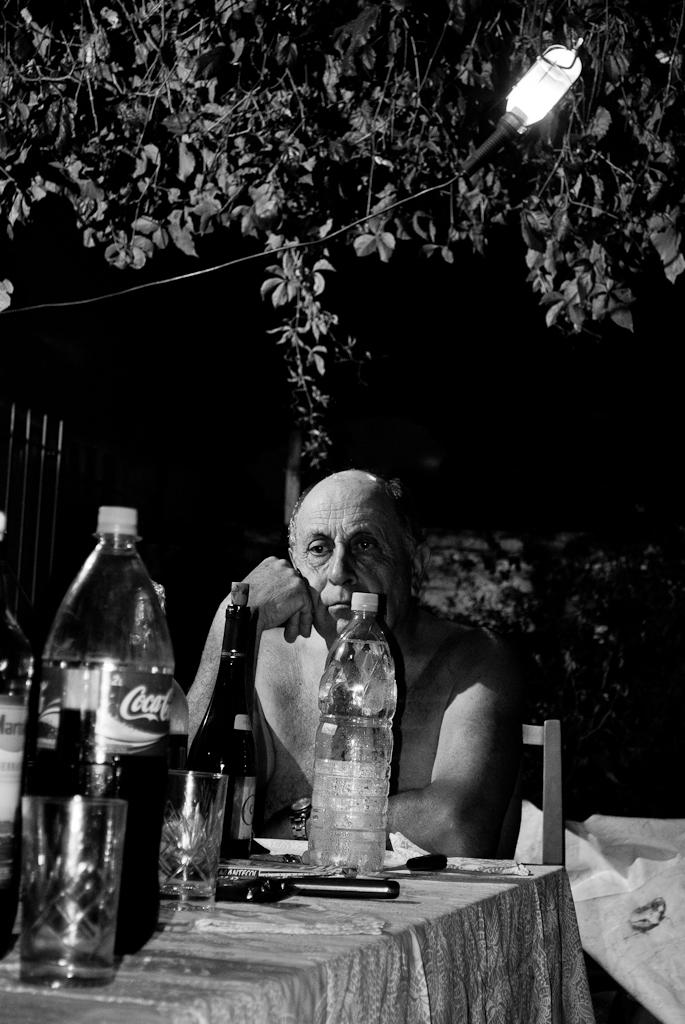Provide a one-sentence caption for the provided image. A man sits shirtless at a table with a bottle of Coca-cola on it. 